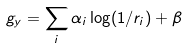<formula> <loc_0><loc_0><loc_500><loc_500>g _ { y } = \sum _ { i } \alpha _ { i } \log ( 1 / r _ { i } ) + \beta</formula> 